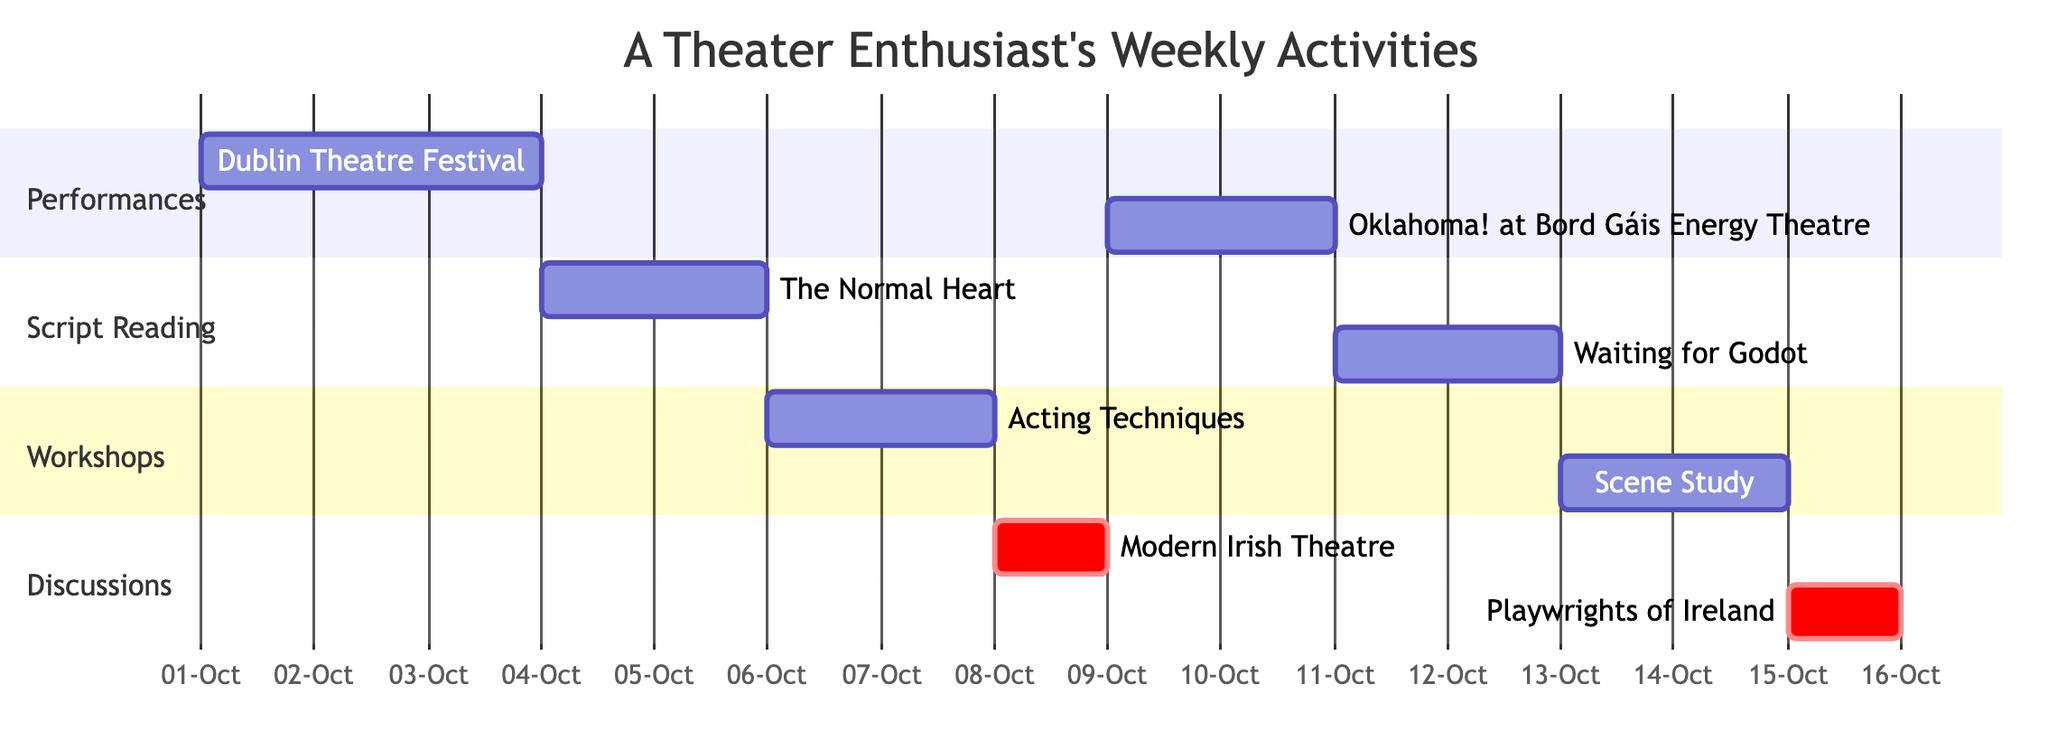What activities are scheduled for the 8th of October? The 8th of October shows only one scheduled activity in the Gantt chart, which is the discussion panel titled "Modern Irish Theatre."
Answer: Modern Irish Theatre How many performances are scheduled in this week? By examining the "Performances" section of the Gantt chart, there are a total of 2 activities listed: "Dublin Theatre Festival" and "Oklahoma!" at Bord Gáis Energy Theatre.
Answer: 2 Which activity takes place for two consecutive days starting from the 6th of October? Looking at the timeline, the "Participate in Workshop - Acting Techniques" starts on the 6th of October and lasts for 2 days until the 7th.
Answer: Participate in Workshop - Acting Techniques What is the start date of the second script reading activity? The second script reading activity is "Waiting for Godot," which starts on the 11th of October according to the "Script Reading" section.
Answer: 2023-10-11 Which workshops are scheduled after attending the Dublin Theatre Festival? After "Dublin Theatre Festival" ends on the 3rd of October, the next workshop scheduled is "Acting Techniques" on the 6th of October, which takes place in a different section of the timeline.
Answer: Acting Techniques What is the total number of discussion panels planned for this week? There are two discussion panels in the Gantt chart: "Modern Irish Theatre" on the 8th and "Playwrights of Ireland" on the 15th.
Answer: 2 In which section does the activity "Attend Performance - 'Oklahoma!' at Bord Gáis Energy Theatre" appear? This activity appears in the "Performances" section of the Gantt chart, which specifically lists various performances attended.
Answer: Performances Which activity has the longest duration according to the Gantt chart? The "Attend Performance - Dublin Theatre Festival" and "Oklahoma!" both take place over 3 and 2 days, respectively, but the performance at the Dublin Theatre Festival is longer at 3 days.
Answer: Attend Performance - Dublin Theatre Festival 